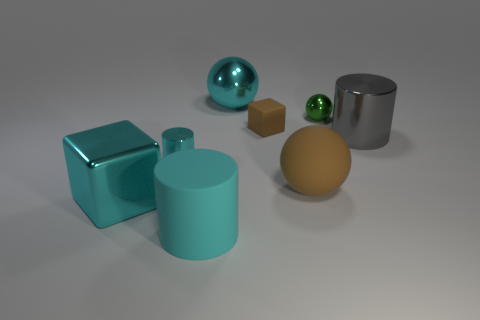What is the large cylinder that is on the right side of the cyan metallic thing that is on the right side of the big cylinder to the left of the large matte ball made of?
Offer a terse response. Metal. Is the large cyan matte thing the same shape as the gray metallic thing?
Provide a short and direct response. Yes. How many shiny objects are behind the brown matte sphere and left of the small green shiny object?
Offer a very short reply. 2. There is a big metallic object that is to the left of the large cyan object that is behind the big gray metallic cylinder; what color is it?
Give a very brief answer. Cyan. Are there an equal number of cubes on the left side of the small rubber block and green objects?
Offer a very short reply. Yes. There is a large cyan shiny sphere on the left side of the large matte thing that is on the right side of the rubber cylinder; what number of small shiny cylinders are in front of it?
Ensure brevity in your answer.  1. What color is the large cylinder that is behind the large brown rubber ball?
Make the answer very short. Gray. There is a large cyan thing that is both behind the large cyan matte cylinder and in front of the brown cube; what is its material?
Your answer should be very brief. Metal. There is a shiny thing behind the green ball; how many small metal objects are to the right of it?
Your response must be concise. 1. The small brown rubber thing is what shape?
Offer a very short reply. Cube. 